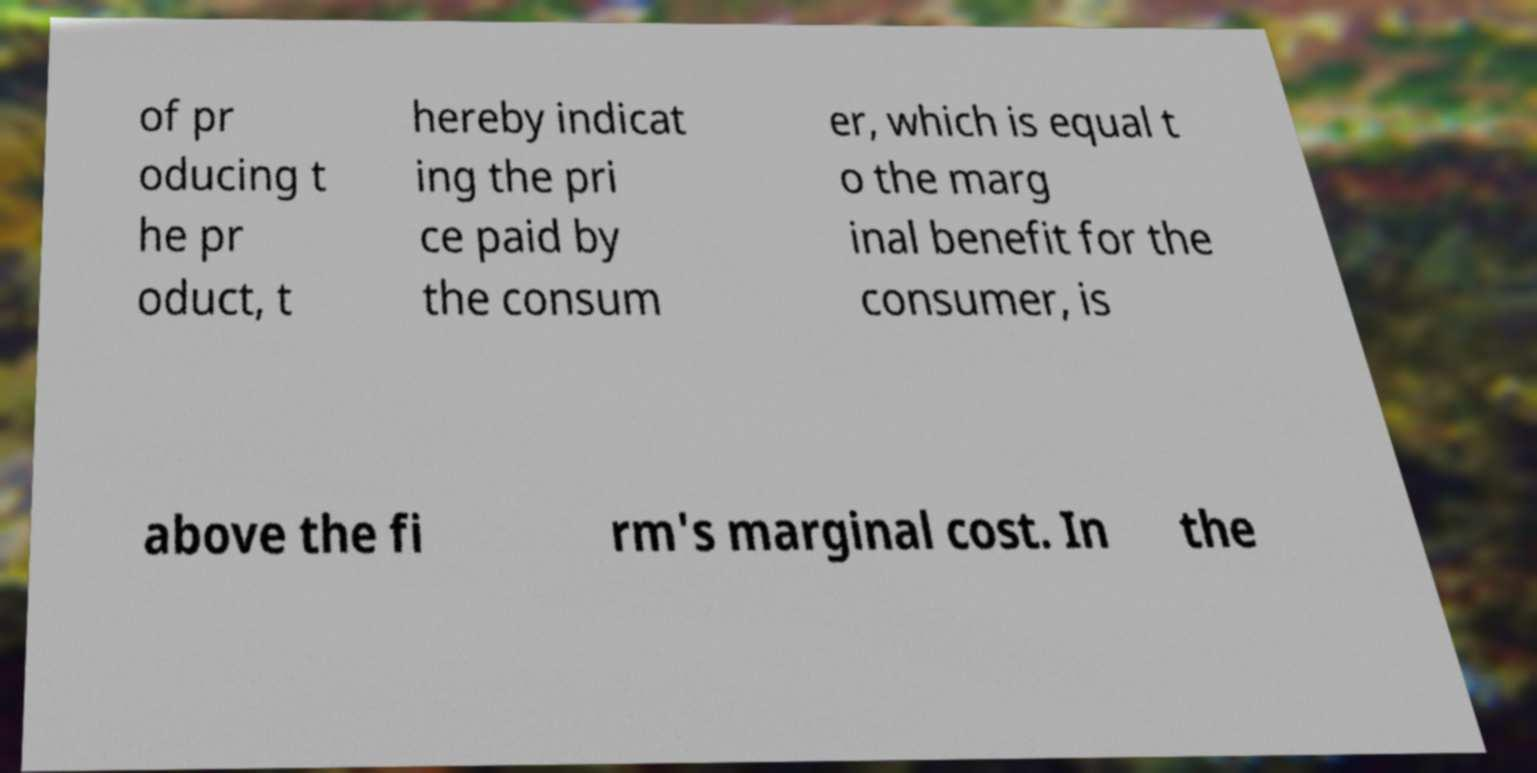For documentation purposes, I need the text within this image transcribed. Could you provide that? of pr oducing t he pr oduct, t hereby indicat ing the pri ce paid by the consum er, which is equal t o the marg inal benefit for the consumer, is above the fi rm's marginal cost. In the 